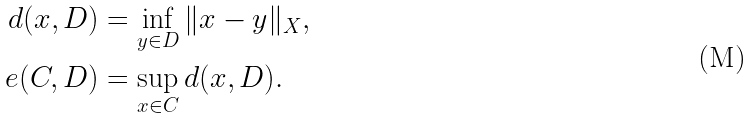<formula> <loc_0><loc_0><loc_500><loc_500>d ( x , D ) & = \inf _ { y \in D } \| x - y \| _ { X } , \\ e ( C , D ) & = \sup _ { x \in C } d ( x , D ) .</formula> 